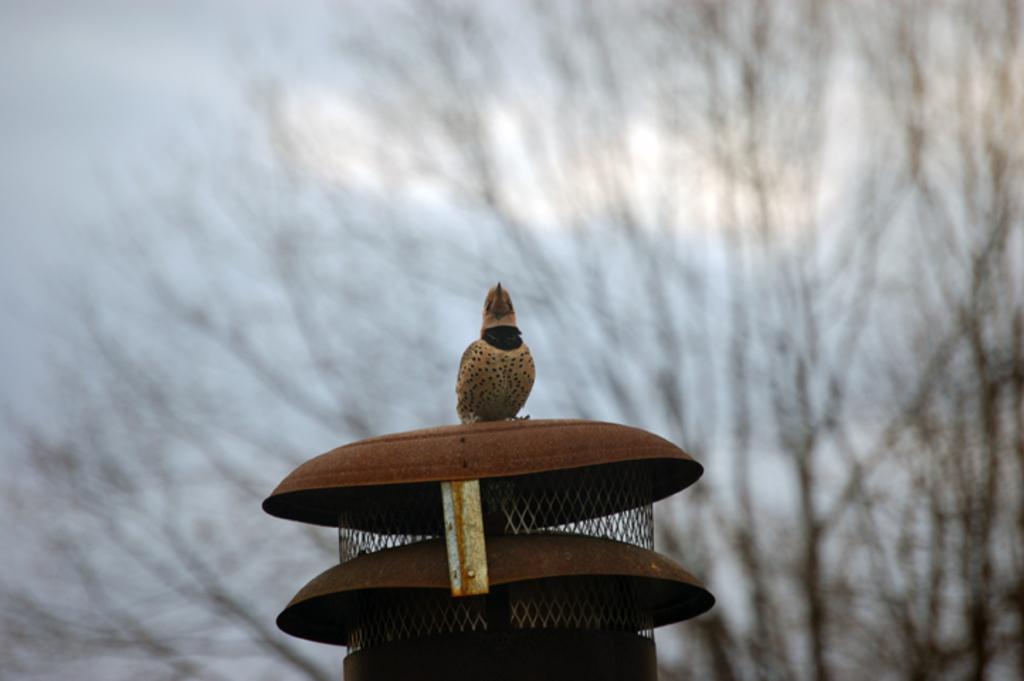Could you give a brief overview of what you see in this image? In this image we can see a metal like structure on which one bird is sitting, behind one tree is there. 